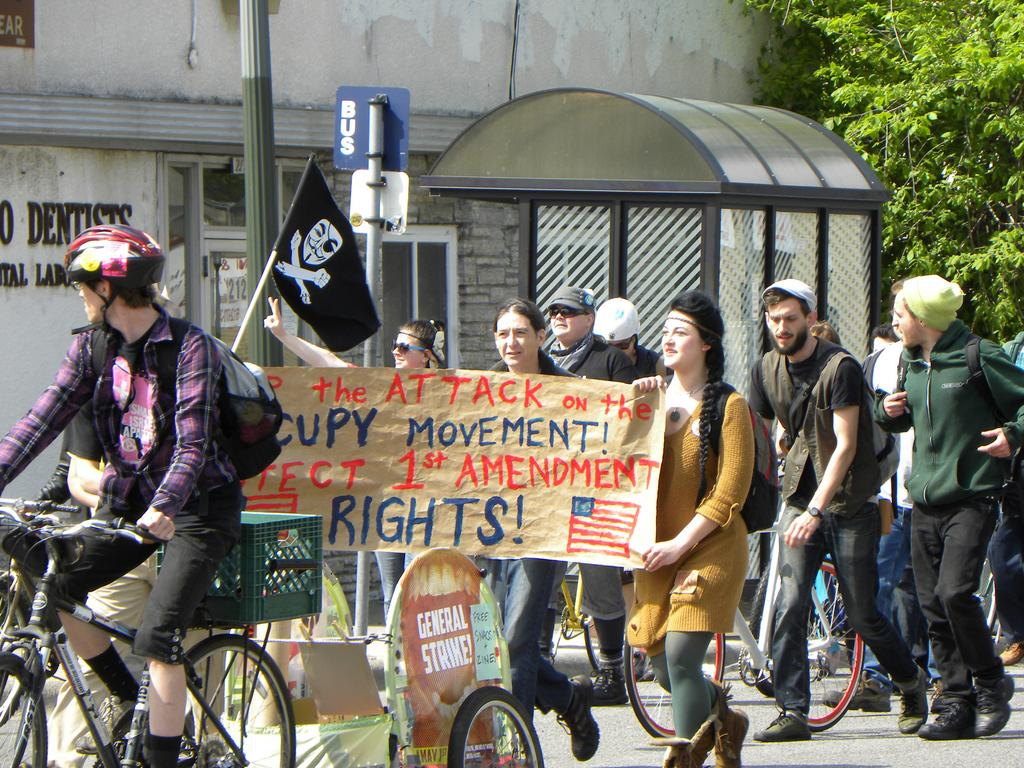What is the man in the image doing? The man is riding a bicycle in the image. What can be seen besides the man riding a bicycle in the image? There is a flag, a group of people walking, a poster, a pole, and a tree in the image. Can you describe the flag in the image? The flag is a distinct feature in the image, but its design or color is not mentioned in the facts provided. What is the group of people doing in the image? The group of people is walking in the image. What is the poster in the image promoting or displaying? The content of the poster is not mentioned in the facts provided. What type of music is the fish playing in the image? There is no fish or music present in the image. 